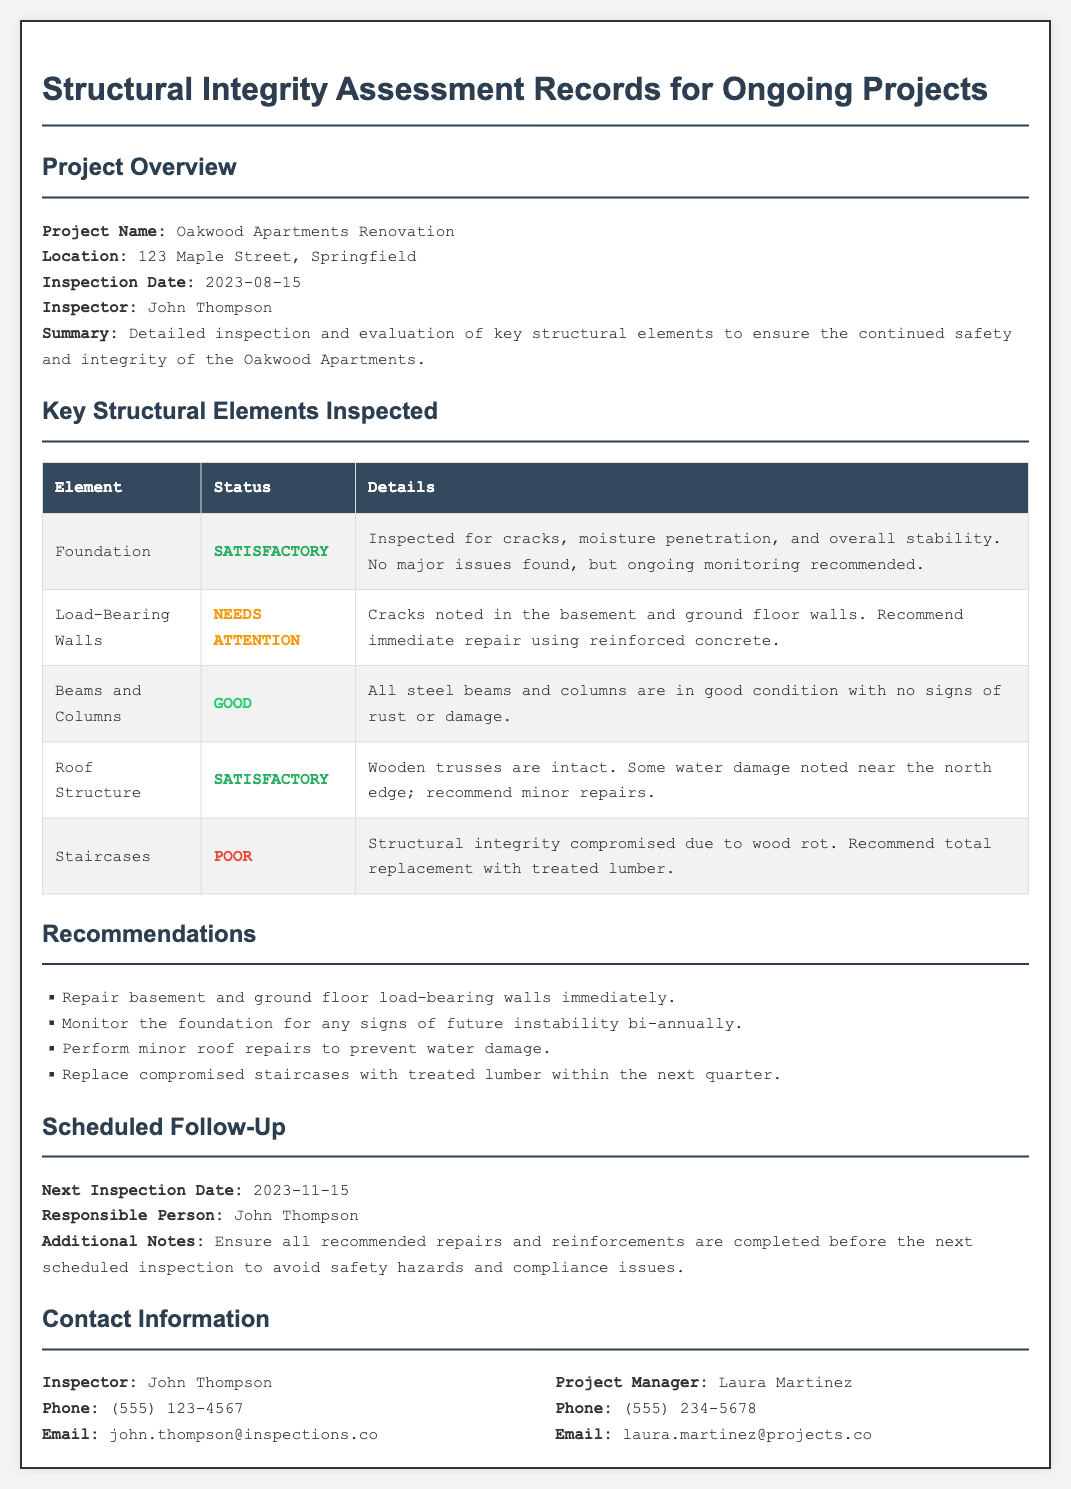What is the project name? The project name is listed in the document under Project Overview.
Answer: Oakwood Apartments Renovation Who conducted the inspection? The inspector's name is found in the Project Overview section.
Answer: John Thompson What is the inspection date? The date of inspection is specified in the Project Overview section.
Answer: 2023-08-15 What is the status of the roof structure? The document provides status updates for each structural element, including the roof structure.
Answer: Satisfactory What repairs are recommended for the staircases? Recommendations for repairs can be found in the Recommendations section.
Answer: Total replacement with treated lumber What should be done about the foundation? Recommendations regarding the foundation are detailed in the Recommendations section.
Answer: Monitor for instability bi-annually How many load-bearing walls need attention? The details on the structural elements can be referenced to find numbers for those needing attention.
Answer: 2 walls (basement and ground floor) When is the next inspection scheduled? The next inspection date is stated in the Scheduled Follow-Up section.
Answer: 2023-11-15 What type of wood is recommended for the staircases? The type of wood for replacement is specified in the Recommendations section.
Answer: Treated lumber 